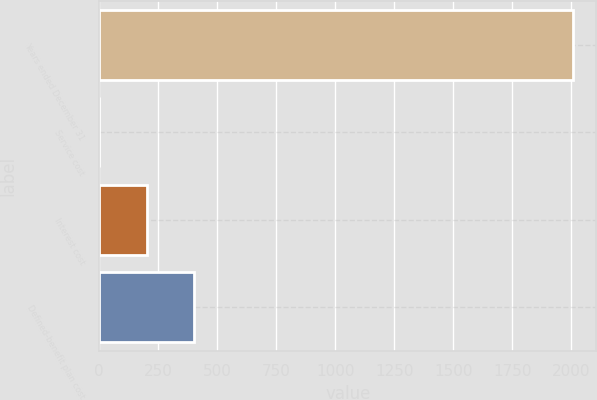Convert chart. <chart><loc_0><loc_0><loc_500><loc_500><bar_chart><fcel>Years ended December 31<fcel>Service cost<fcel>Interest cost<fcel>Defined-benefit plan cost<nl><fcel>2006<fcel>0.2<fcel>200.78<fcel>401.36<nl></chart> 